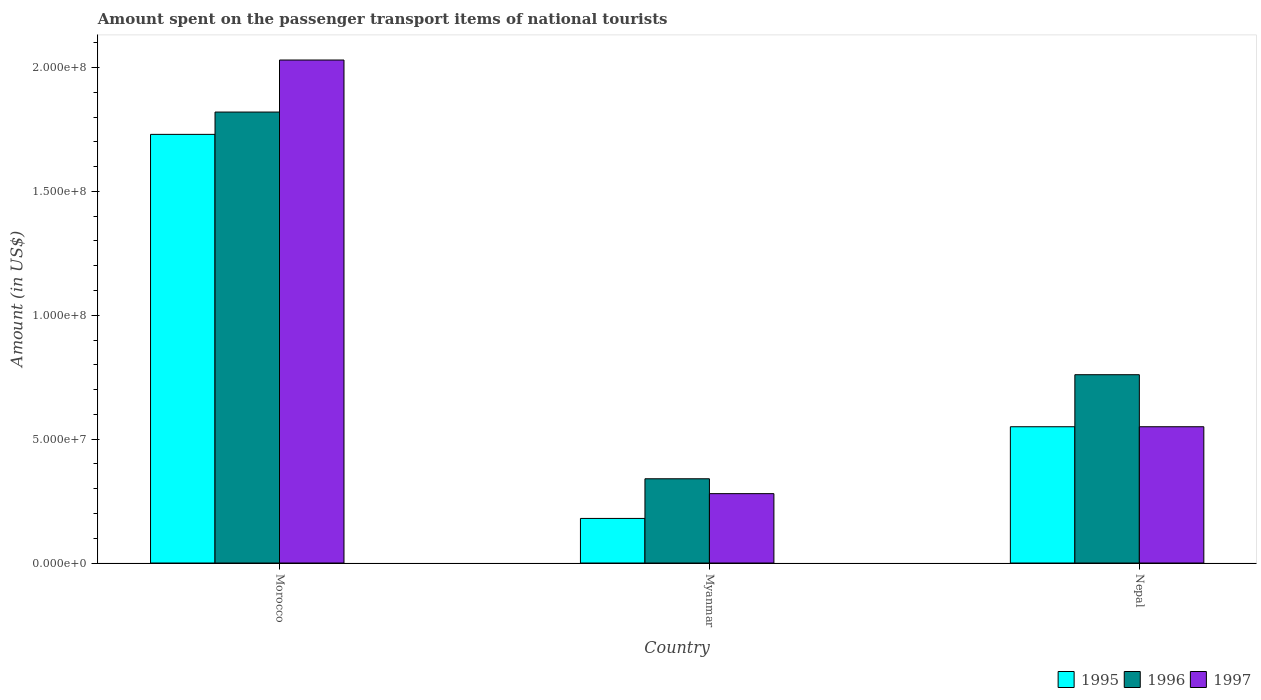How many different coloured bars are there?
Make the answer very short. 3. Are the number of bars per tick equal to the number of legend labels?
Your answer should be very brief. Yes. How many bars are there on the 3rd tick from the left?
Provide a succinct answer. 3. How many bars are there on the 1st tick from the right?
Your answer should be compact. 3. What is the label of the 3rd group of bars from the left?
Offer a terse response. Nepal. In how many cases, is the number of bars for a given country not equal to the number of legend labels?
Provide a succinct answer. 0. What is the amount spent on the passenger transport items of national tourists in 1995 in Myanmar?
Provide a short and direct response. 1.80e+07. Across all countries, what is the maximum amount spent on the passenger transport items of national tourists in 1996?
Your answer should be compact. 1.82e+08. Across all countries, what is the minimum amount spent on the passenger transport items of national tourists in 1996?
Keep it short and to the point. 3.40e+07. In which country was the amount spent on the passenger transport items of national tourists in 1995 maximum?
Your answer should be very brief. Morocco. In which country was the amount spent on the passenger transport items of national tourists in 1996 minimum?
Your answer should be compact. Myanmar. What is the total amount spent on the passenger transport items of national tourists in 1995 in the graph?
Your answer should be very brief. 2.46e+08. What is the difference between the amount spent on the passenger transport items of national tourists in 1997 in Morocco and that in Nepal?
Your answer should be very brief. 1.48e+08. What is the difference between the amount spent on the passenger transport items of national tourists in 1996 in Nepal and the amount spent on the passenger transport items of national tourists in 1995 in Morocco?
Make the answer very short. -9.70e+07. What is the average amount spent on the passenger transport items of national tourists in 1996 per country?
Offer a very short reply. 9.73e+07. What is the difference between the amount spent on the passenger transport items of national tourists of/in 1995 and amount spent on the passenger transport items of national tourists of/in 1996 in Nepal?
Ensure brevity in your answer.  -2.10e+07. In how many countries, is the amount spent on the passenger transport items of national tourists in 1997 greater than 60000000 US$?
Your answer should be very brief. 1. What is the ratio of the amount spent on the passenger transport items of national tourists in 1996 in Morocco to that in Nepal?
Keep it short and to the point. 2.39. Is the amount spent on the passenger transport items of national tourists in 1995 in Morocco less than that in Myanmar?
Provide a succinct answer. No. What is the difference between the highest and the second highest amount spent on the passenger transport items of national tourists in 1996?
Ensure brevity in your answer.  1.06e+08. What is the difference between the highest and the lowest amount spent on the passenger transport items of national tourists in 1995?
Provide a succinct answer. 1.55e+08. What does the 2nd bar from the right in Myanmar represents?
Your answer should be very brief. 1996. How many bars are there?
Give a very brief answer. 9. Are all the bars in the graph horizontal?
Make the answer very short. No. What is the difference between two consecutive major ticks on the Y-axis?
Provide a succinct answer. 5.00e+07. Are the values on the major ticks of Y-axis written in scientific E-notation?
Keep it short and to the point. Yes. How are the legend labels stacked?
Give a very brief answer. Horizontal. What is the title of the graph?
Keep it short and to the point. Amount spent on the passenger transport items of national tourists. Does "2004" appear as one of the legend labels in the graph?
Provide a succinct answer. No. What is the label or title of the X-axis?
Offer a terse response. Country. What is the Amount (in US$) in 1995 in Morocco?
Give a very brief answer. 1.73e+08. What is the Amount (in US$) in 1996 in Morocco?
Offer a very short reply. 1.82e+08. What is the Amount (in US$) of 1997 in Morocco?
Offer a very short reply. 2.03e+08. What is the Amount (in US$) in 1995 in Myanmar?
Keep it short and to the point. 1.80e+07. What is the Amount (in US$) of 1996 in Myanmar?
Provide a succinct answer. 3.40e+07. What is the Amount (in US$) in 1997 in Myanmar?
Keep it short and to the point. 2.80e+07. What is the Amount (in US$) in 1995 in Nepal?
Offer a very short reply. 5.50e+07. What is the Amount (in US$) of 1996 in Nepal?
Your response must be concise. 7.60e+07. What is the Amount (in US$) in 1997 in Nepal?
Provide a succinct answer. 5.50e+07. Across all countries, what is the maximum Amount (in US$) of 1995?
Offer a terse response. 1.73e+08. Across all countries, what is the maximum Amount (in US$) of 1996?
Offer a very short reply. 1.82e+08. Across all countries, what is the maximum Amount (in US$) of 1997?
Your answer should be compact. 2.03e+08. Across all countries, what is the minimum Amount (in US$) of 1995?
Ensure brevity in your answer.  1.80e+07. Across all countries, what is the minimum Amount (in US$) of 1996?
Keep it short and to the point. 3.40e+07. Across all countries, what is the minimum Amount (in US$) of 1997?
Offer a very short reply. 2.80e+07. What is the total Amount (in US$) in 1995 in the graph?
Your answer should be compact. 2.46e+08. What is the total Amount (in US$) of 1996 in the graph?
Make the answer very short. 2.92e+08. What is the total Amount (in US$) in 1997 in the graph?
Your response must be concise. 2.86e+08. What is the difference between the Amount (in US$) of 1995 in Morocco and that in Myanmar?
Provide a short and direct response. 1.55e+08. What is the difference between the Amount (in US$) of 1996 in Morocco and that in Myanmar?
Ensure brevity in your answer.  1.48e+08. What is the difference between the Amount (in US$) in 1997 in Morocco and that in Myanmar?
Offer a very short reply. 1.75e+08. What is the difference between the Amount (in US$) of 1995 in Morocco and that in Nepal?
Make the answer very short. 1.18e+08. What is the difference between the Amount (in US$) in 1996 in Morocco and that in Nepal?
Provide a short and direct response. 1.06e+08. What is the difference between the Amount (in US$) in 1997 in Morocco and that in Nepal?
Your answer should be very brief. 1.48e+08. What is the difference between the Amount (in US$) in 1995 in Myanmar and that in Nepal?
Keep it short and to the point. -3.70e+07. What is the difference between the Amount (in US$) of 1996 in Myanmar and that in Nepal?
Provide a succinct answer. -4.20e+07. What is the difference between the Amount (in US$) of 1997 in Myanmar and that in Nepal?
Make the answer very short. -2.70e+07. What is the difference between the Amount (in US$) in 1995 in Morocco and the Amount (in US$) in 1996 in Myanmar?
Your answer should be very brief. 1.39e+08. What is the difference between the Amount (in US$) of 1995 in Morocco and the Amount (in US$) of 1997 in Myanmar?
Offer a very short reply. 1.45e+08. What is the difference between the Amount (in US$) in 1996 in Morocco and the Amount (in US$) in 1997 in Myanmar?
Make the answer very short. 1.54e+08. What is the difference between the Amount (in US$) of 1995 in Morocco and the Amount (in US$) of 1996 in Nepal?
Your answer should be very brief. 9.70e+07. What is the difference between the Amount (in US$) in 1995 in Morocco and the Amount (in US$) in 1997 in Nepal?
Provide a succinct answer. 1.18e+08. What is the difference between the Amount (in US$) of 1996 in Morocco and the Amount (in US$) of 1997 in Nepal?
Make the answer very short. 1.27e+08. What is the difference between the Amount (in US$) in 1995 in Myanmar and the Amount (in US$) in 1996 in Nepal?
Your response must be concise. -5.80e+07. What is the difference between the Amount (in US$) in 1995 in Myanmar and the Amount (in US$) in 1997 in Nepal?
Provide a short and direct response. -3.70e+07. What is the difference between the Amount (in US$) in 1996 in Myanmar and the Amount (in US$) in 1997 in Nepal?
Give a very brief answer. -2.10e+07. What is the average Amount (in US$) in 1995 per country?
Keep it short and to the point. 8.20e+07. What is the average Amount (in US$) of 1996 per country?
Your response must be concise. 9.73e+07. What is the average Amount (in US$) in 1997 per country?
Your response must be concise. 9.53e+07. What is the difference between the Amount (in US$) of 1995 and Amount (in US$) of 1996 in Morocco?
Make the answer very short. -9.00e+06. What is the difference between the Amount (in US$) in 1995 and Amount (in US$) in 1997 in Morocco?
Offer a terse response. -3.00e+07. What is the difference between the Amount (in US$) of 1996 and Amount (in US$) of 1997 in Morocco?
Offer a terse response. -2.10e+07. What is the difference between the Amount (in US$) in 1995 and Amount (in US$) in 1996 in Myanmar?
Your response must be concise. -1.60e+07. What is the difference between the Amount (in US$) in 1995 and Amount (in US$) in 1997 in Myanmar?
Provide a succinct answer. -1.00e+07. What is the difference between the Amount (in US$) in 1996 and Amount (in US$) in 1997 in Myanmar?
Provide a short and direct response. 6.00e+06. What is the difference between the Amount (in US$) in 1995 and Amount (in US$) in 1996 in Nepal?
Offer a terse response. -2.10e+07. What is the difference between the Amount (in US$) of 1995 and Amount (in US$) of 1997 in Nepal?
Provide a succinct answer. 0. What is the difference between the Amount (in US$) of 1996 and Amount (in US$) of 1997 in Nepal?
Offer a very short reply. 2.10e+07. What is the ratio of the Amount (in US$) of 1995 in Morocco to that in Myanmar?
Keep it short and to the point. 9.61. What is the ratio of the Amount (in US$) of 1996 in Morocco to that in Myanmar?
Your answer should be compact. 5.35. What is the ratio of the Amount (in US$) of 1997 in Morocco to that in Myanmar?
Offer a very short reply. 7.25. What is the ratio of the Amount (in US$) of 1995 in Morocco to that in Nepal?
Your response must be concise. 3.15. What is the ratio of the Amount (in US$) in 1996 in Morocco to that in Nepal?
Offer a very short reply. 2.39. What is the ratio of the Amount (in US$) in 1997 in Morocco to that in Nepal?
Your answer should be compact. 3.69. What is the ratio of the Amount (in US$) in 1995 in Myanmar to that in Nepal?
Offer a terse response. 0.33. What is the ratio of the Amount (in US$) in 1996 in Myanmar to that in Nepal?
Offer a terse response. 0.45. What is the ratio of the Amount (in US$) in 1997 in Myanmar to that in Nepal?
Offer a terse response. 0.51. What is the difference between the highest and the second highest Amount (in US$) of 1995?
Your answer should be very brief. 1.18e+08. What is the difference between the highest and the second highest Amount (in US$) of 1996?
Make the answer very short. 1.06e+08. What is the difference between the highest and the second highest Amount (in US$) of 1997?
Offer a terse response. 1.48e+08. What is the difference between the highest and the lowest Amount (in US$) in 1995?
Your answer should be very brief. 1.55e+08. What is the difference between the highest and the lowest Amount (in US$) in 1996?
Ensure brevity in your answer.  1.48e+08. What is the difference between the highest and the lowest Amount (in US$) of 1997?
Make the answer very short. 1.75e+08. 